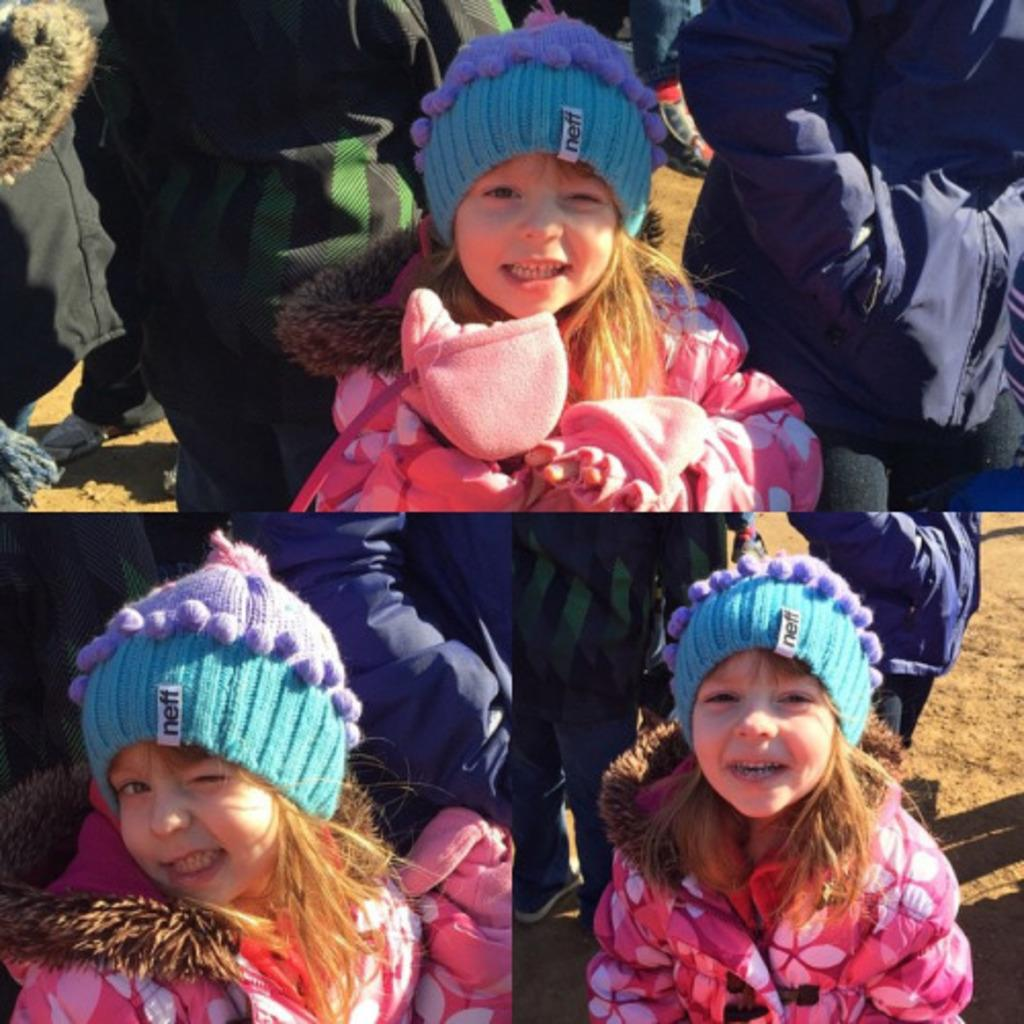What is the main feature of the image? The image contains a collage of three pictures. Can you describe one of the pictures in the collage? There is a little girl in one of the pictures. What is the little girl wearing in her picture? The little girl is wearing a jacket and a cap. Are there any other people visible in the little girl's picture? Yes, there are other people visible in the background of the little girl's picture. What type of beast can be seen in the image? There is no beast present in the image; it contains a collage of three pictures, one of which features a little girl. 